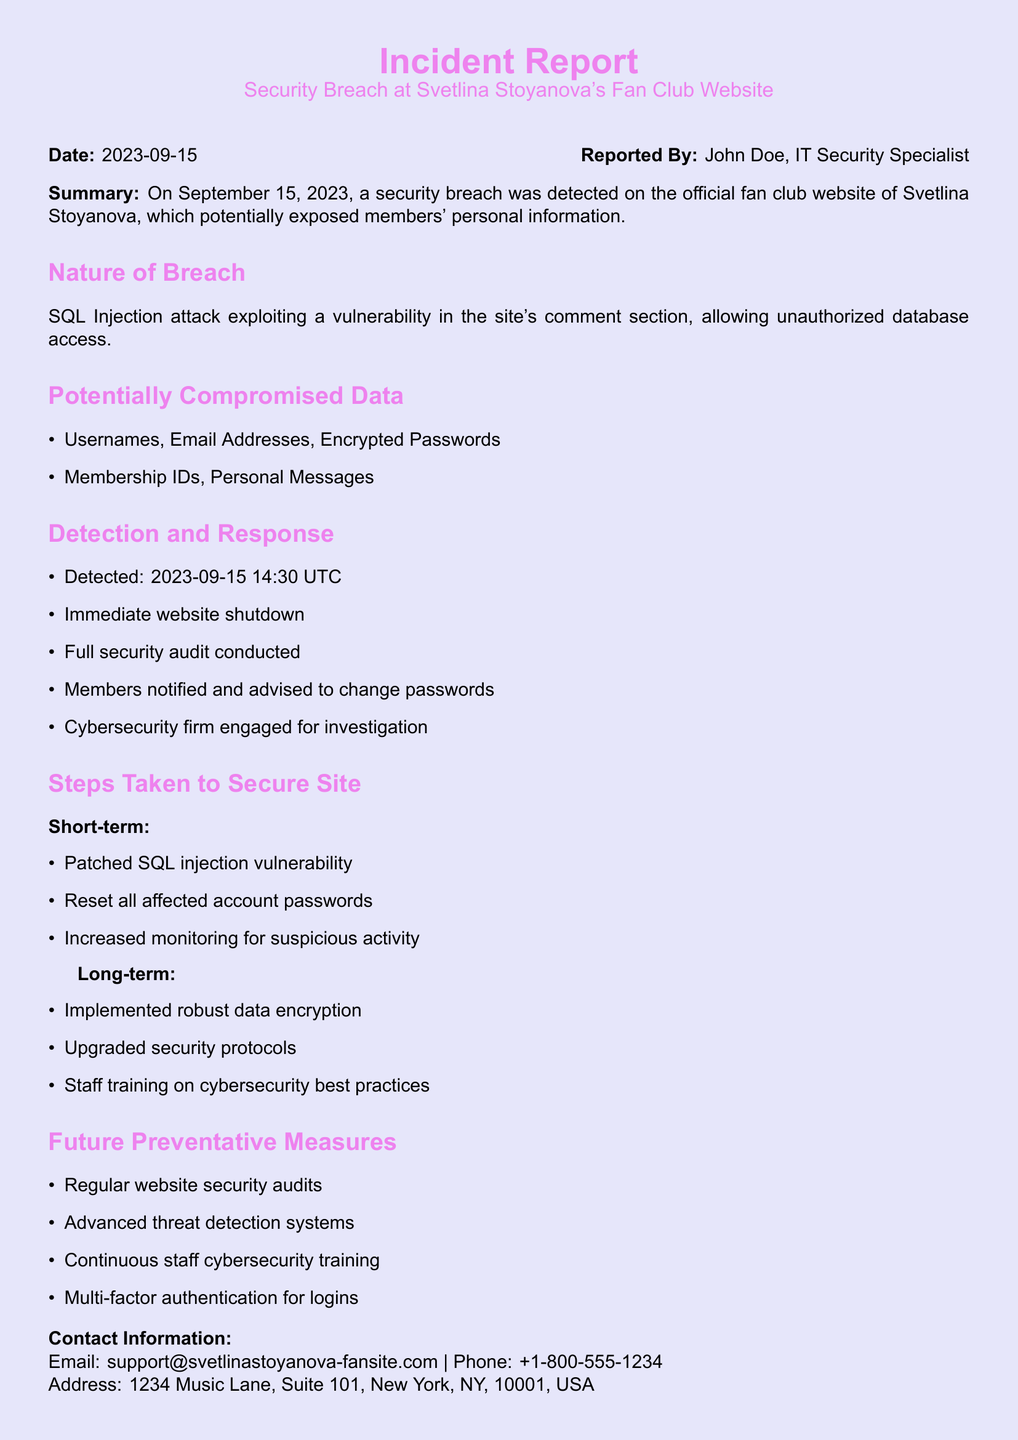What date was the security breach detected? The date the breach was detected is specified in the report as September 15, 2023.
Answer: September 15, 2023 What type of attack was reported? The document details that the nature of the breach involved an SQL Injection attack.
Answer: SQL Injection Who reported the incident? The report lists John Doe as the person who reported the incident.
Answer: John Doe What immediate action was taken after detection? The report mentions that the immediate action taken was a website shutdown.
Answer: Website shutdown What data was potentially compromised? A list of compromised data includes usernames, email addresses, and encrypted passwords.
Answer: Usernames, Email Addresses, Encrypted Passwords How was the SQL vulnerability addressed? The report states that the SQL injection vulnerability was patched in the short-term actions taken.
Answer: Patched What future measure is mentioned for logins? The document suggests implementing multi-factor authentication as a future preventative measure for logins.
Answer: Multi-factor authentication When was the detection time of the breach? The breach detection time is recorded as 14:30 UTC on September 15, 2023.
Answer: 14:30 UTC What long-term security upgrade was implemented? Long-term measures include upgrading security protocols as a step to secure the site.
Answer: Upgraded security protocols How many types of personal information were listed as compromised? The report lists two types of personal information at risk: usernames, email addresses, and encrypted passwords.
Answer: Three types 